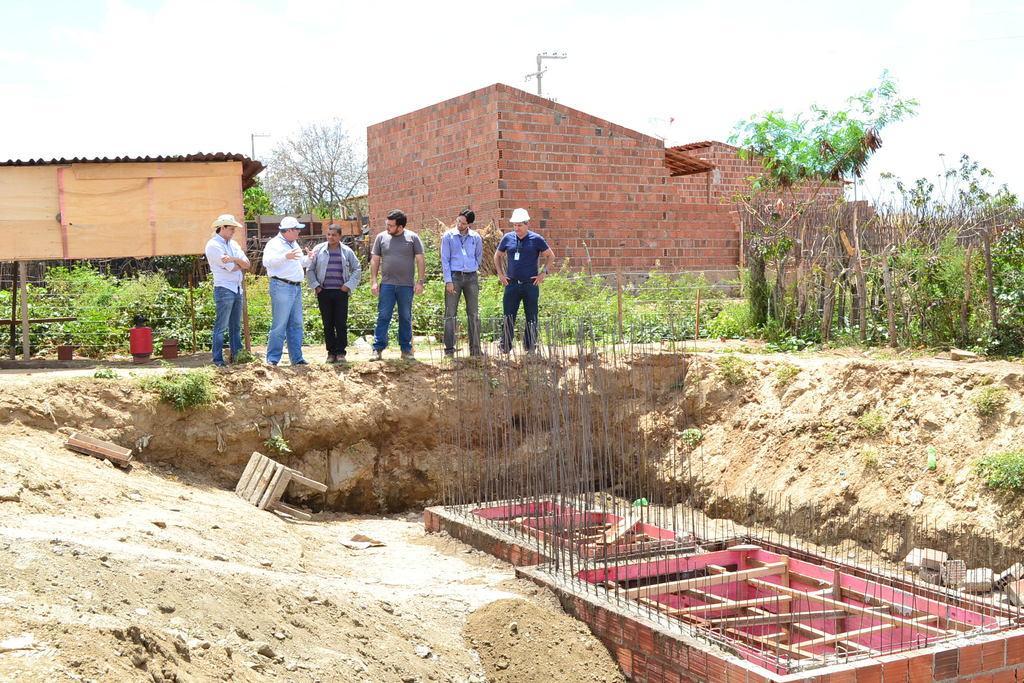How would you summarize this image in a sentence or two? In this picture, we can see a few people, ground and some objects on the ground like wooden objects, metallic objects, wooden frames, chair, grass, plants, fencing, and we can see houses, poles, and the sky. 